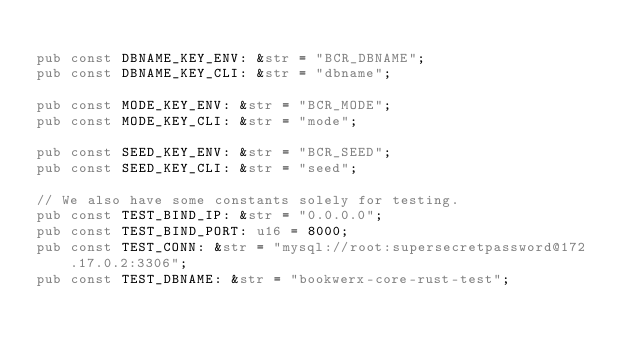<code> <loc_0><loc_0><loc_500><loc_500><_Rust_>
pub const DBNAME_KEY_ENV: &str = "BCR_DBNAME";
pub const DBNAME_KEY_CLI: &str = "dbname";

pub const MODE_KEY_ENV: &str = "BCR_MODE";
pub const MODE_KEY_CLI: &str = "mode";

pub const SEED_KEY_ENV: &str = "BCR_SEED";
pub const SEED_KEY_CLI: &str = "seed";

// We also have some constants solely for testing.
pub const TEST_BIND_IP: &str = "0.0.0.0";
pub const TEST_BIND_PORT: u16 = 8000;
pub const TEST_CONN: &str = "mysql://root:supersecretpassword@172.17.0.2:3306";
pub const TEST_DBNAME: &str = "bookwerx-core-rust-test";
</code> 